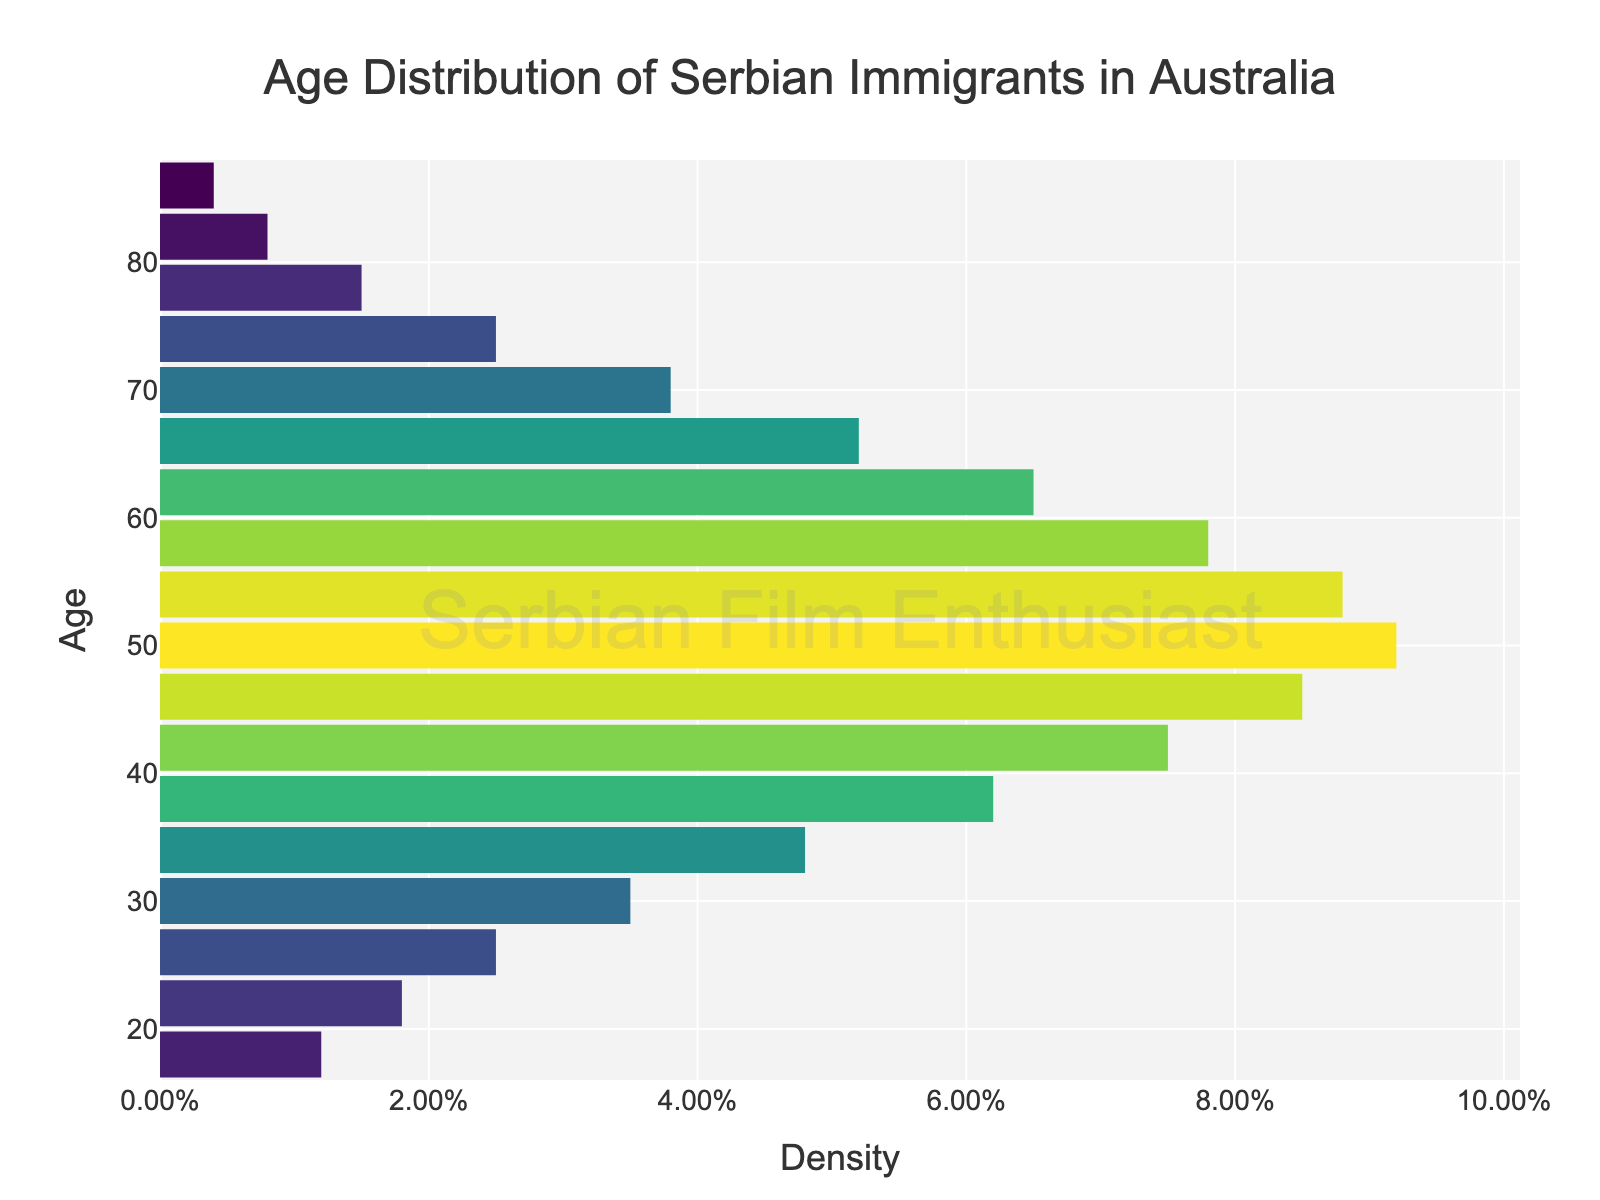What is the title of the figure? The title of the figure is usually found at the top. For this figure, it reads "Age Distribution of Serbian Immigrants in Australia".
Answer: Age Distribution of Serbian Immigrants in Australia What are the x-axis and y-axis titles? The x-axis title is "Density" and the y-axis title is "Age". These titles are positioned along their respective axes and are clearly labeled.
Answer: Density and Age At what age is the density highest for Serbian immigrants in Australia? The density values peak at the age corresponding to the highest bar in the plot. The age with the highest density is 50 years.
Answer: 50 years What is the density for Serbian immigrants who are 30 years old? Find the bar corresponding to the age of 30 years, then look at the x-axis to see its height. The density for this age is 0.035.
Answer: 0.035 How does the density for 74-year-olds compare to that for 38-year-olds? Compare the height of the bars for 74-year-olds and 38-year-olds. The density for 38-year-olds (0.062) is higher than for 74-year-olds (0.025).
Answer: 38-year-olds have a higher density What is the difference in density between immigrants aged 50 and 82? The density for 50-year-olds is 0.092, and for 82-year-olds is 0.008. Subtract the latter from the former: 0.092 - 0.008 = 0.084.
Answer: 0.084 At what range of ages does the density start to significantly decline? Observe where the bars start decreasing noticeably. The density starts to significantly decline after the age of 54.
Answer: After 54 years What is the total number of data points (age groups) displayed in the figure? Count the number of bars representing different age groups. There are 18 age groups displayed in the plot.
Answer: 18 What is the average density of Serbian immigrants from age 18 to 86? Sum all density values from age 18 to 86 and divide by the number of data points (18). The sum is 0.012 + 0.018 + 0.025 + 0.035 + 0.048 + 0.062 + 0.075 + 0.085 + 0.092 + 0.088 + 0.078 + 0.065 + 0.052 + 0.038 + 0.025 + 0.015 + 0.008 + 0.004 = 0.835. The average is 0.835 / 18 ≈ 0.0464.
Answer: Approximately 0.0464 What color scheme is used for representing the density values? The density values are color-coded using the 'Viridis' colorscale, which includes a range of colors from yellow to blue to green.
Answer: Viridis 